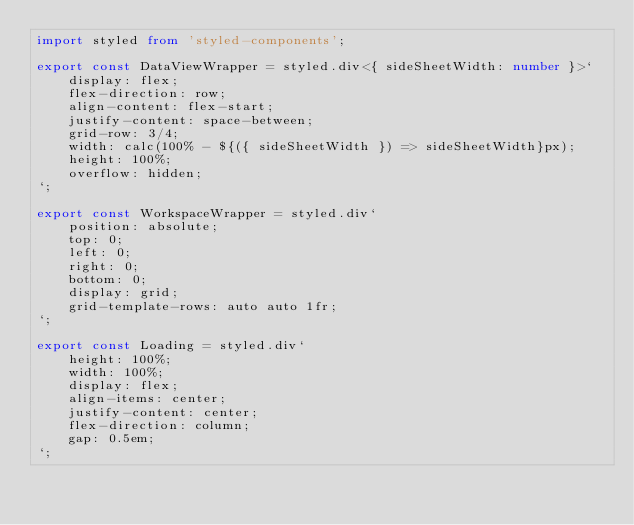Convert code to text. <code><loc_0><loc_0><loc_500><loc_500><_TypeScript_>import styled from 'styled-components';

export const DataViewWrapper = styled.div<{ sideSheetWidth: number }>`
    display: flex;
    flex-direction: row;
    align-content: flex-start;
    justify-content: space-between;
    grid-row: 3/4;
    width: calc(100% - ${({ sideSheetWidth }) => sideSheetWidth}px);
    height: 100%;
    overflow: hidden;
`;

export const WorkspaceWrapper = styled.div`
    position: absolute;
    top: 0;
    left: 0;
    right: 0;
    bottom: 0;
    display: grid;
    grid-template-rows: auto auto 1fr;
`;

export const Loading = styled.div`
    height: 100%;
    width: 100%;
    display: flex;
    align-items: center;
    justify-content: center;
    flex-direction: column;
    gap: 0.5em;
`;
</code> 